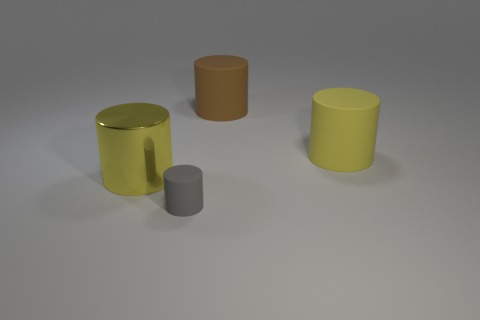Add 4 large blue metal cubes. How many objects exist? 8 Add 4 large brown things. How many large brown things are left? 5 Add 4 big metallic things. How many big metallic things exist? 5 Subtract 0 cyan balls. How many objects are left? 4 Subtract all big yellow matte cylinders. Subtract all big brown cylinders. How many objects are left? 2 